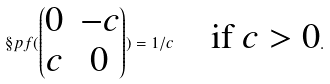<formula> <loc_0><loc_0><loc_500><loc_500>\S p f ( \begin{pmatrix} 0 & - c \\ c & 0 \end{pmatrix} ) = 1 / c \quad \text {if $c>0$} .</formula> 